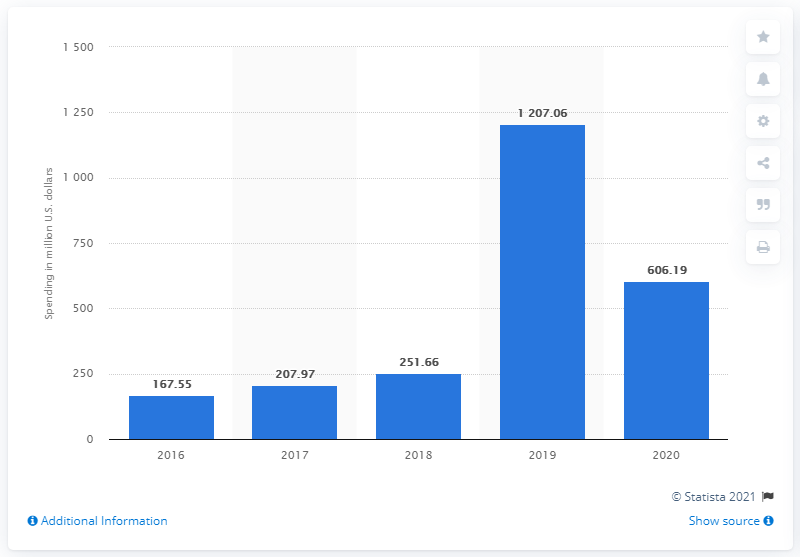Specify some key components in this picture. In 2019, Pinterest's R&D expenses were approximately $120.706 million. Pinterest's most recent year's R&D expenditure was 606.19.. 